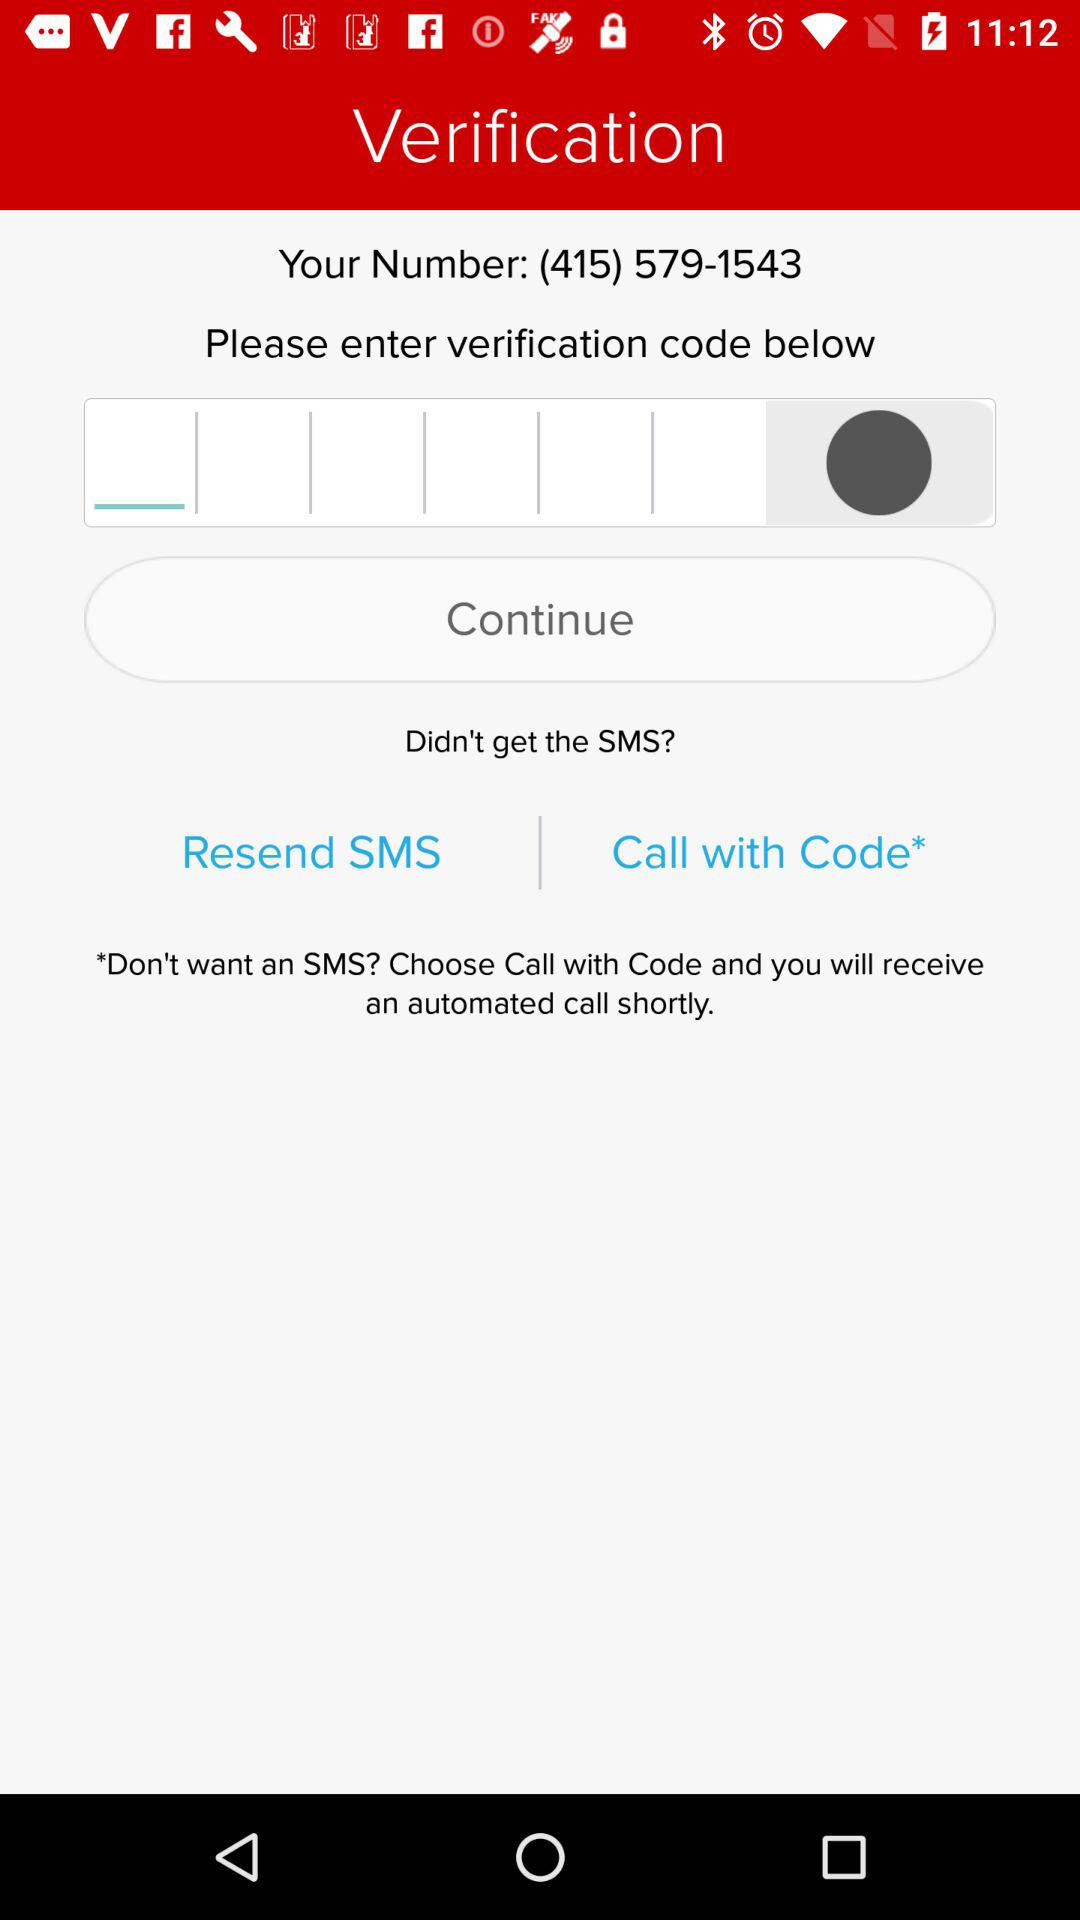What is the verification code?
When the provided information is insufficient, respond with <no answer>. <no answer> 